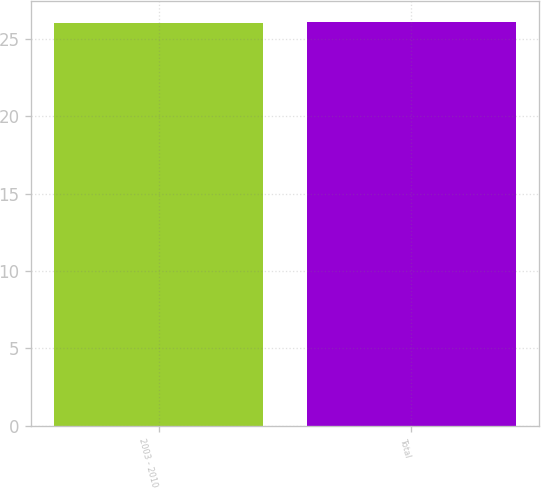Convert chart. <chart><loc_0><loc_0><loc_500><loc_500><bar_chart><fcel>2003 - 2010<fcel>Total<nl><fcel>26<fcel>26.1<nl></chart> 